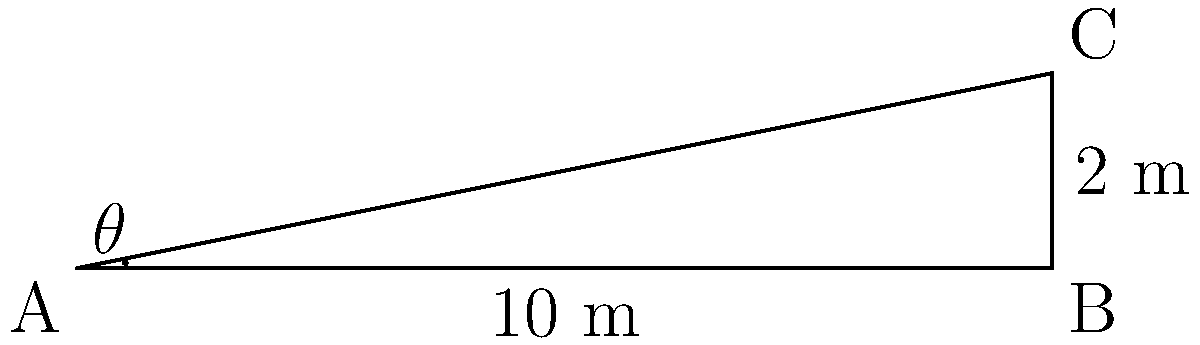As part of an urban development project in Kazipara, Dhaka, you're tasked with designing an accessible ramp. The ramp needs to rise 2 meters over a horizontal distance of 10 meters. Using trigonometric ratios, calculate the angle of elevation (θ) of the ramp to the nearest degree. To solve this problem, we'll use the tangent ratio in trigonometry. Here's the step-by-step solution:

1) In a right-angled triangle, tangent of an angle is the ratio of the opposite side to the adjacent side.

2) In this case:
   - The rise of 2 meters is the opposite side
   - The horizontal distance of 10 meters is the adjacent side

3) We can write this as:

   $$\tan(\theta) = \frac{\text{opposite}}{\text{adjacent}} = \frac{2}{10} = 0.2$$

4) To find θ, we need to use the inverse tangent (arctan or tan^(-1)):

   $$\theta = \tan^{-1}(0.2)$$

5) Using a calculator or trigonometric tables:

   $$\theta \approx 11.31^\circ$$

6) Rounding to the nearest degree:

   $$\theta \approx 11^\circ$$

Therefore, the angle of elevation of the ramp is approximately 11°.
Answer: 11° 